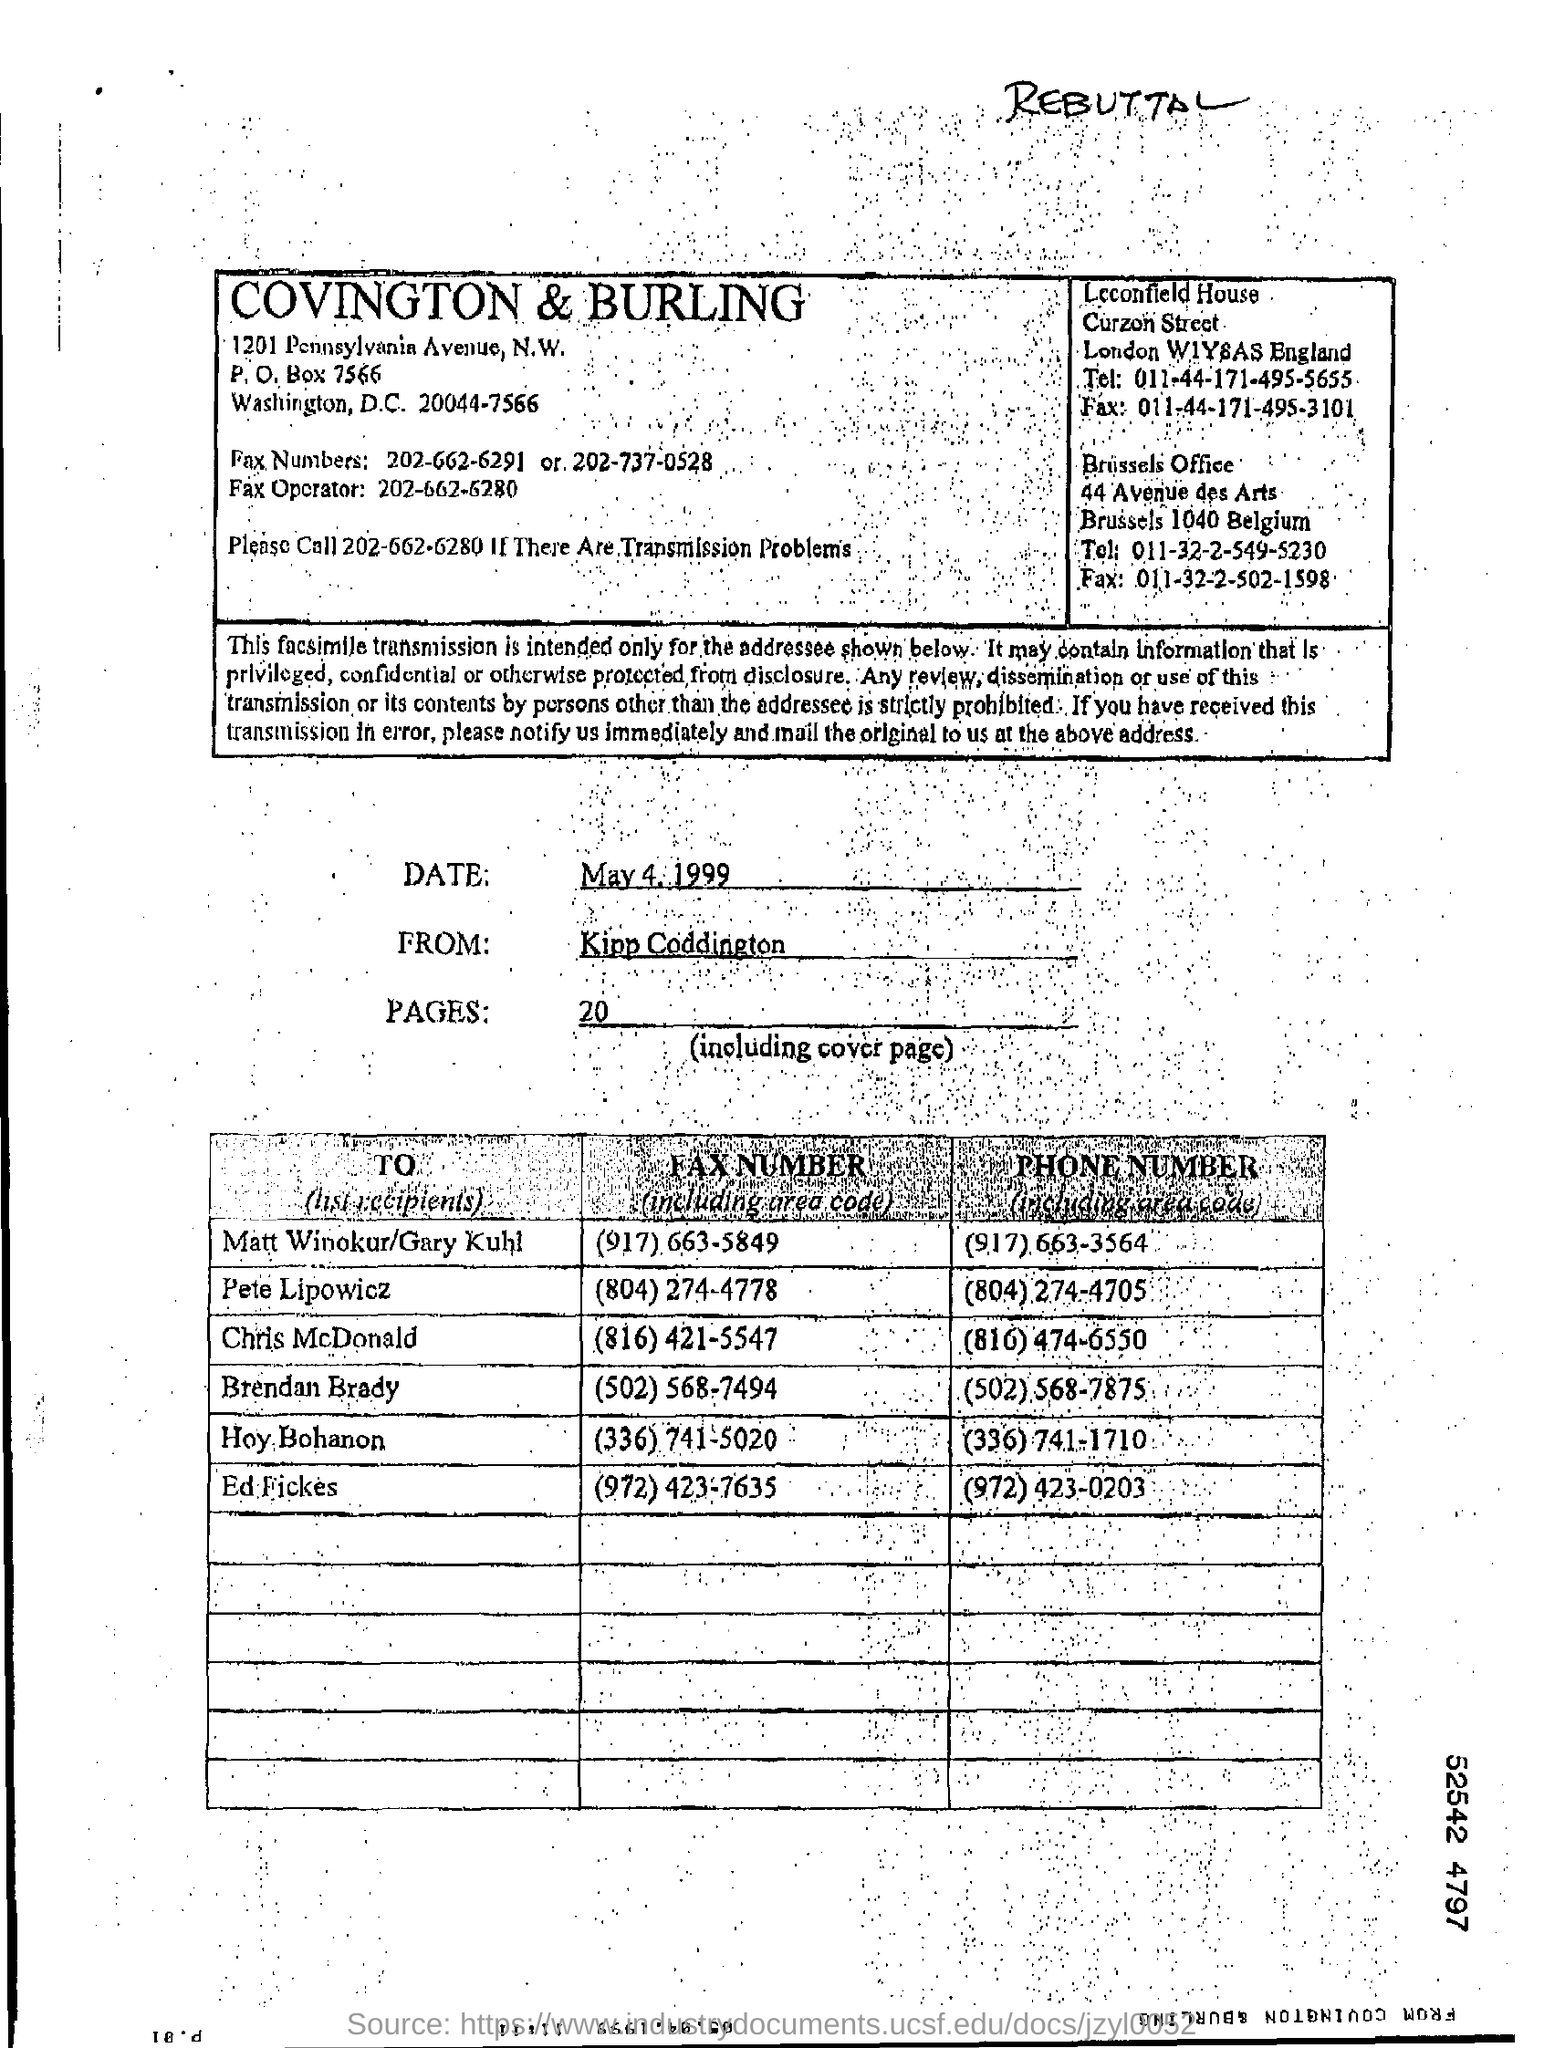Who is the sender of the Fax?
Ensure brevity in your answer.  Kipp Coddington. What is the date of fax transmission?
Keep it short and to the point. May 4, 1999. What is the no of pages in the fax including cover page?
Your answer should be very brief. 20. What is the fax no of Ed Fickes?
Your answer should be compact. (972) 423-7635. What is the phone no of Chris McDonald?
Make the answer very short. (816) 474-6550. 